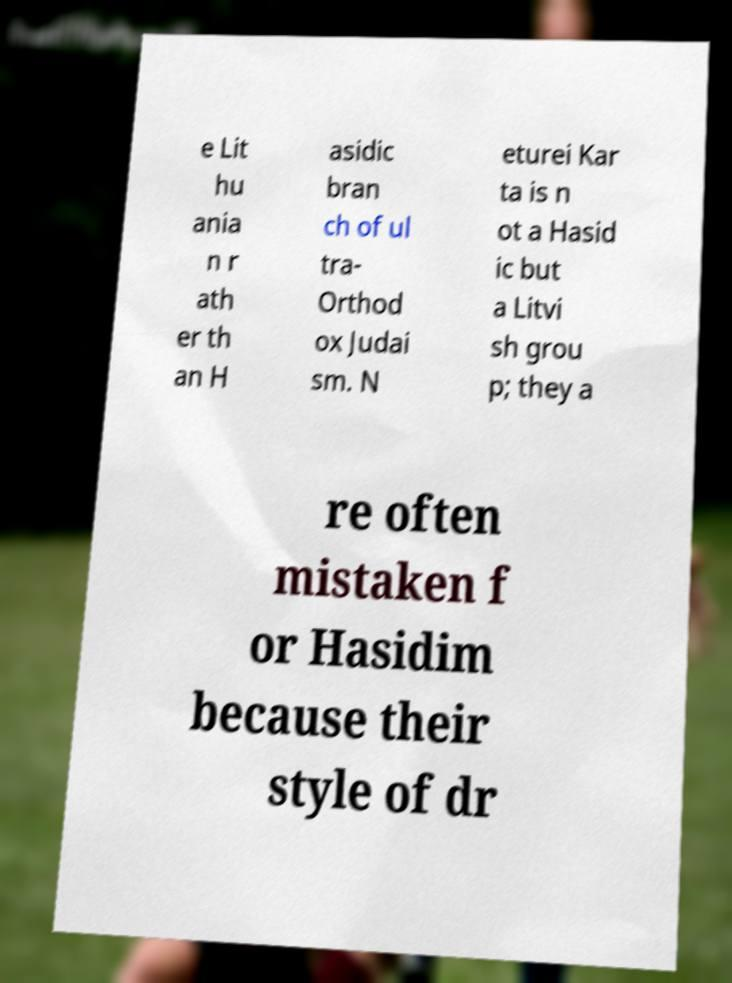Please identify and transcribe the text found in this image. e Lit hu ania n r ath er th an H asidic bran ch of ul tra- Orthod ox Judai sm. N eturei Kar ta is n ot a Hasid ic but a Litvi sh grou p; they a re often mistaken f or Hasidim because their style of dr 